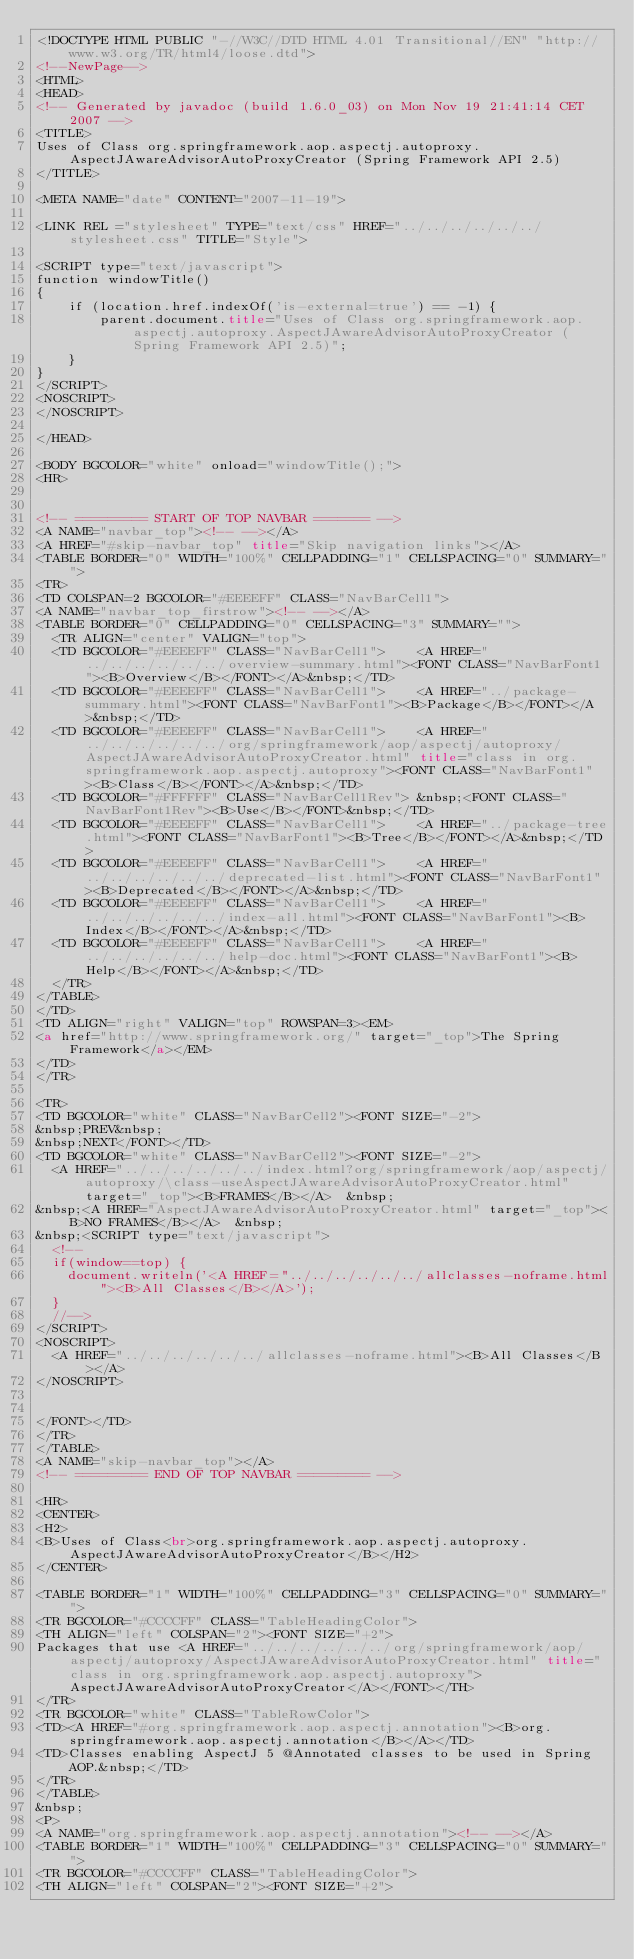Convert code to text. <code><loc_0><loc_0><loc_500><loc_500><_HTML_><!DOCTYPE HTML PUBLIC "-//W3C//DTD HTML 4.01 Transitional//EN" "http://www.w3.org/TR/html4/loose.dtd">
<!--NewPage-->
<HTML>
<HEAD>
<!-- Generated by javadoc (build 1.6.0_03) on Mon Nov 19 21:41:14 CET 2007 -->
<TITLE>
Uses of Class org.springframework.aop.aspectj.autoproxy.AspectJAwareAdvisorAutoProxyCreator (Spring Framework API 2.5)
</TITLE>

<META NAME="date" CONTENT="2007-11-19">

<LINK REL ="stylesheet" TYPE="text/css" HREF="../../../../../../stylesheet.css" TITLE="Style">

<SCRIPT type="text/javascript">
function windowTitle()
{
    if (location.href.indexOf('is-external=true') == -1) {
        parent.document.title="Uses of Class org.springframework.aop.aspectj.autoproxy.AspectJAwareAdvisorAutoProxyCreator (Spring Framework API 2.5)";
    }
}
</SCRIPT>
<NOSCRIPT>
</NOSCRIPT>

</HEAD>

<BODY BGCOLOR="white" onload="windowTitle();">
<HR>


<!-- ========= START OF TOP NAVBAR ======= -->
<A NAME="navbar_top"><!-- --></A>
<A HREF="#skip-navbar_top" title="Skip navigation links"></A>
<TABLE BORDER="0" WIDTH="100%" CELLPADDING="1" CELLSPACING="0" SUMMARY="">
<TR>
<TD COLSPAN=2 BGCOLOR="#EEEEFF" CLASS="NavBarCell1">
<A NAME="navbar_top_firstrow"><!-- --></A>
<TABLE BORDER="0" CELLPADDING="0" CELLSPACING="3" SUMMARY="">
  <TR ALIGN="center" VALIGN="top">
  <TD BGCOLOR="#EEEEFF" CLASS="NavBarCell1">    <A HREF="../../../../../../overview-summary.html"><FONT CLASS="NavBarFont1"><B>Overview</B></FONT></A>&nbsp;</TD>
  <TD BGCOLOR="#EEEEFF" CLASS="NavBarCell1">    <A HREF="../package-summary.html"><FONT CLASS="NavBarFont1"><B>Package</B></FONT></A>&nbsp;</TD>
  <TD BGCOLOR="#EEEEFF" CLASS="NavBarCell1">    <A HREF="../../../../../../org/springframework/aop/aspectj/autoproxy/AspectJAwareAdvisorAutoProxyCreator.html" title="class in org.springframework.aop.aspectj.autoproxy"><FONT CLASS="NavBarFont1"><B>Class</B></FONT></A>&nbsp;</TD>
  <TD BGCOLOR="#FFFFFF" CLASS="NavBarCell1Rev"> &nbsp;<FONT CLASS="NavBarFont1Rev"><B>Use</B></FONT>&nbsp;</TD>
  <TD BGCOLOR="#EEEEFF" CLASS="NavBarCell1">    <A HREF="../package-tree.html"><FONT CLASS="NavBarFont1"><B>Tree</B></FONT></A>&nbsp;</TD>
  <TD BGCOLOR="#EEEEFF" CLASS="NavBarCell1">    <A HREF="../../../../../../deprecated-list.html"><FONT CLASS="NavBarFont1"><B>Deprecated</B></FONT></A>&nbsp;</TD>
  <TD BGCOLOR="#EEEEFF" CLASS="NavBarCell1">    <A HREF="../../../../../../index-all.html"><FONT CLASS="NavBarFont1"><B>Index</B></FONT></A>&nbsp;</TD>
  <TD BGCOLOR="#EEEEFF" CLASS="NavBarCell1">    <A HREF="../../../../../../help-doc.html"><FONT CLASS="NavBarFont1"><B>Help</B></FONT></A>&nbsp;</TD>
  </TR>
</TABLE>
</TD>
<TD ALIGN="right" VALIGN="top" ROWSPAN=3><EM>
<a href="http://www.springframework.org/" target="_top">The Spring Framework</a></EM>
</TD>
</TR>

<TR>
<TD BGCOLOR="white" CLASS="NavBarCell2"><FONT SIZE="-2">
&nbsp;PREV&nbsp;
&nbsp;NEXT</FONT></TD>
<TD BGCOLOR="white" CLASS="NavBarCell2"><FONT SIZE="-2">
  <A HREF="../../../../../../index.html?org/springframework/aop/aspectj/autoproxy/\class-useAspectJAwareAdvisorAutoProxyCreator.html" target="_top"><B>FRAMES</B></A>  &nbsp;
&nbsp;<A HREF="AspectJAwareAdvisorAutoProxyCreator.html" target="_top"><B>NO FRAMES</B></A>  &nbsp;
&nbsp;<SCRIPT type="text/javascript">
  <!--
  if(window==top) {
    document.writeln('<A HREF="../../../../../../allclasses-noframe.html"><B>All Classes</B></A>');
  }
  //-->
</SCRIPT>
<NOSCRIPT>
  <A HREF="../../../../../../allclasses-noframe.html"><B>All Classes</B></A>
</NOSCRIPT>


</FONT></TD>
</TR>
</TABLE>
<A NAME="skip-navbar_top"></A>
<!-- ========= END OF TOP NAVBAR ========= -->

<HR>
<CENTER>
<H2>
<B>Uses of Class<br>org.springframework.aop.aspectj.autoproxy.AspectJAwareAdvisorAutoProxyCreator</B></H2>
</CENTER>

<TABLE BORDER="1" WIDTH="100%" CELLPADDING="3" CELLSPACING="0" SUMMARY="">
<TR BGCOLOR="#CCCCFF" CLASS="TableHeadingColor">
<TH ALIGN="left" COLSPAN="2"><FONT SIZE="+2">
Packages that use <A HREF="../../../../../../org/springframework/aop/aspectj/autoproxy/AspectJAwareAdvisorAutoProxyCreator.html" title="class in org.springframework.aop.aspectj.autoproxy">AspectJAwareAdvisorAutoProxyCreator</A></FONT></TH>
</TR>
<TR BGCOLOR="white" CLASS="TableRowColor">
<TD><A HREF="#org.springframework.aop.aspectj.annotation"><B>org.springframework.aop.aspectj.annotation</B></A></TD>
<TD>Classes enabling AspectJ 5 @Annotated classes to be used in Spring AOP.&nbsp;</TD>
</TR>
</TABLE>
&nbsp;
<P>
<A NAME="org.springframework.aop.aspectj.annotation"><!-- --></A>
<TABLE BORDER="1" WIDTH="100%" CELLPADDING="3" CELLSPACING="0" SUMMARY="">
<TR BGCOLOR="#CCCCFF" CLASS="TableHeadingColor">
<TH ALIGN="left" COLSPAN="2"><FONT SIZE="+2"></code> 